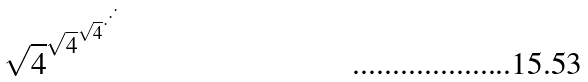<formula> <loc_0><loc_0><loc_500><loc_500>\sqrt { 4 } ^ { \sqrt { 4 } ^ { \sqrt { 4 } ^ { \cdot ^ { \cdot ^ { \cdot } } } } }</formula> 